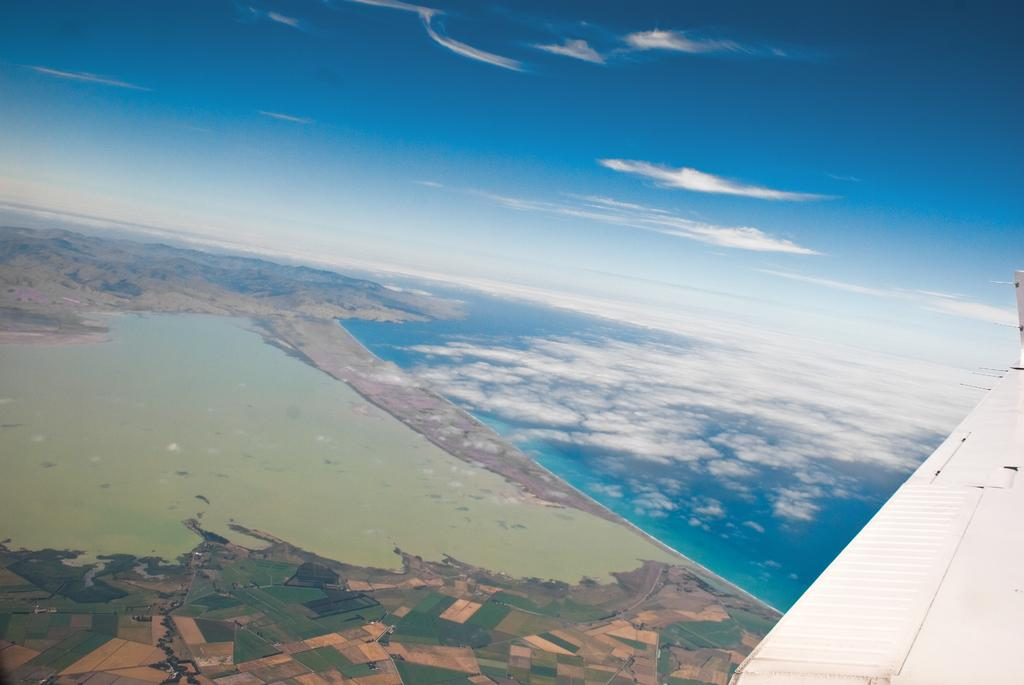What is the main subject of the picture? The main subject of the picture is an airplane wing. What can be seen on the left side of the wing? There are fields and water on the left side of the wing. What is visible above the wing? The sky is visible on the left side of the wing. Can you see a cracker floating on the water in the image? There is no cracker visible in the image; it only features an airplane wing, fields, water, and the sky. 